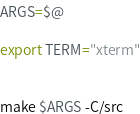Convert code to text. <code><loc_0><loc_0><loc_500><loc_500><_Bash_>
ARGS=$@

export TERM="xterm"


make $ARGS -C/src


</code> 